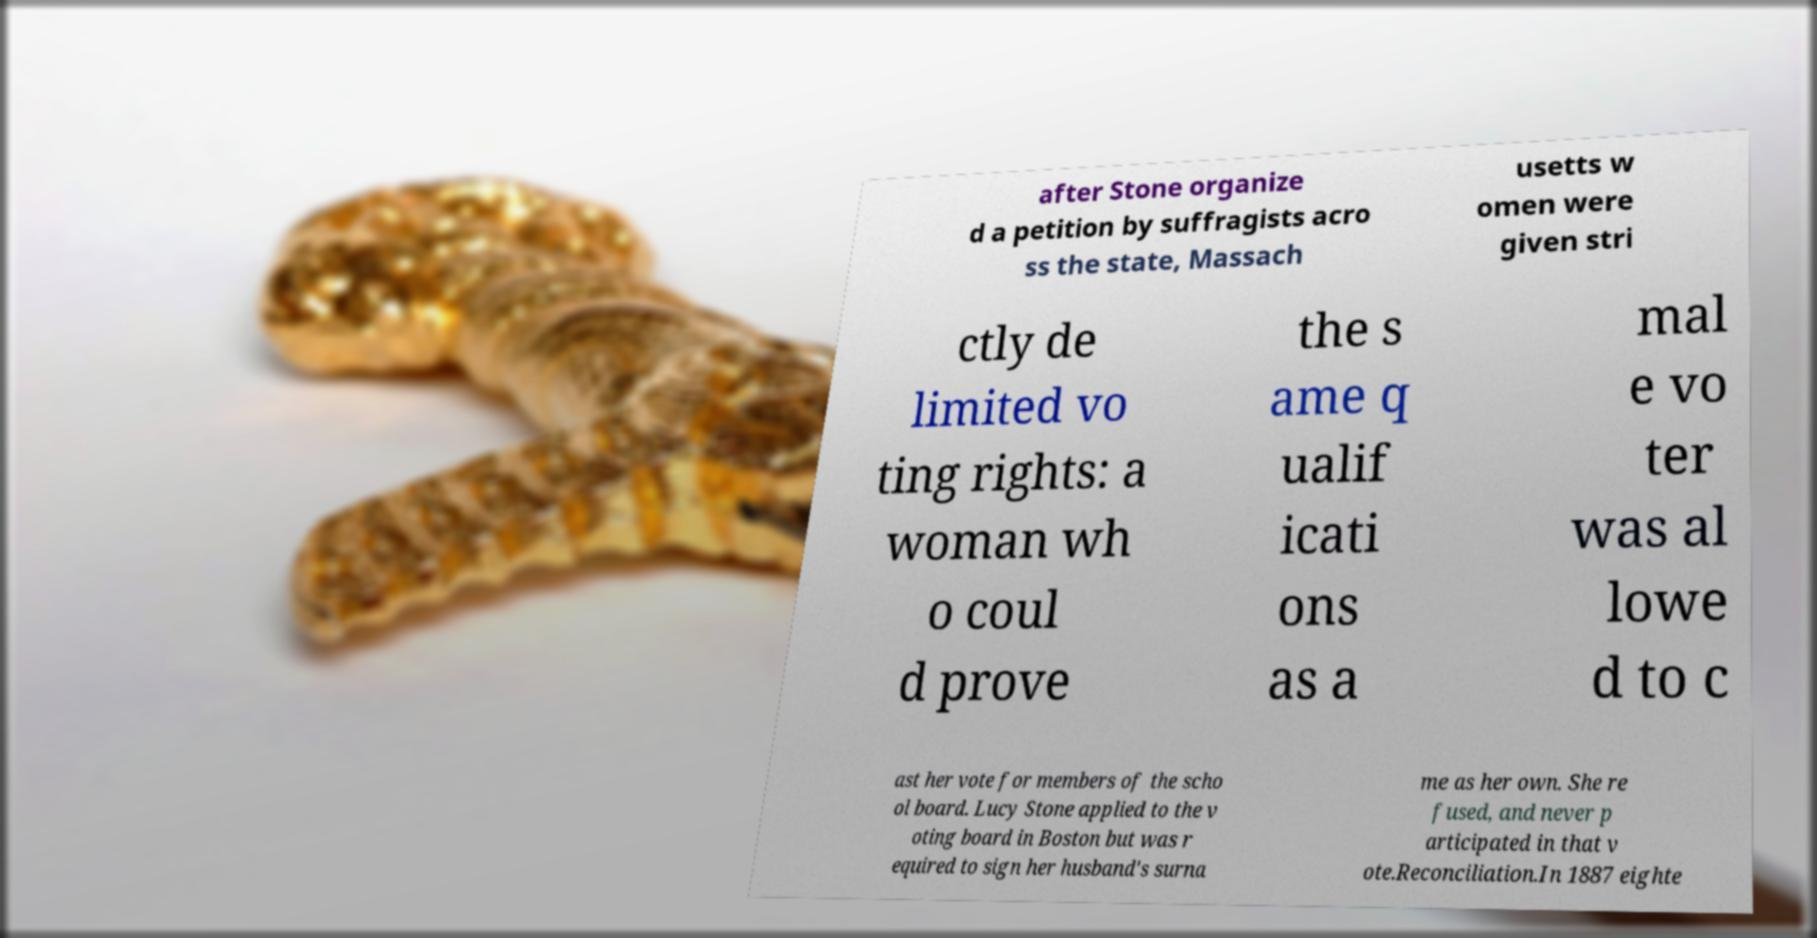Can you accurately transcribe the text from the provided image for me? after Stone organize d a petition by suffragists acro ss the state, Massach usetts w omen were given stri ctly de limited vo ting rights: a woman wh o coul d prove the s ame q ualif icati ons as a mal e vo ter was al lowe d to c ast her vote for members of the scho ol board. Lucy Stone applied to the v oting board in Boston but was r equired to sign her husband's surna me as her own. She re fused, and never p articipated in that v ote.Reconciliation.In 1887 eighte 